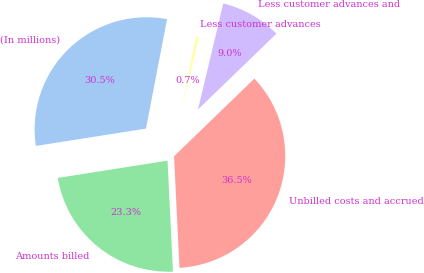<chart> <loc_0><loc_0><loc_500><loc_500><pie_chart><fcel>(In millions)<fcel>Amounts billed<fcel>Unbilled costs and accrued<fcel>Less customer advances and<fcel>Less customer advances<nl><fcel>30.52%<fcel>23.29%<fcel>36.46%<fcel>9.05%<fcel>0.69%<nl></chart> 